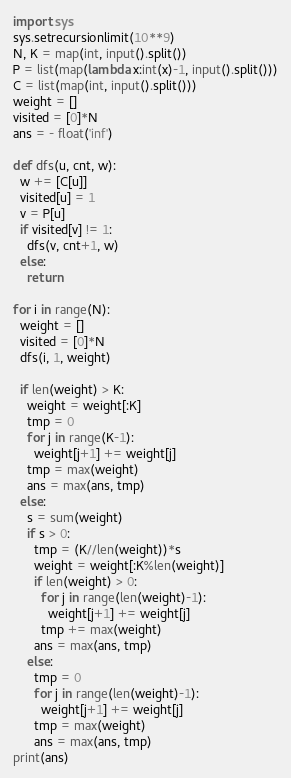Convert code to text. <code><loc_0><loc_0><loc_500><loc_500><_Python_>import sys
sys.setrecursionlimit(10**9)
N, K = map(int, input().split())
P = list(map(lambda x:int(x)-1, input().split()))
C = list(map(int, input().split()))
weight = []
visited = [0]*N
ans = - float('inf')

def dfs(u, cnt, w):
  w += [C[u]]
  visited[u] = 1
  v = P[u]
  if visited[v] != 1:
    dfs(v, cnt+1, w)
  else:
    return

for i in range(N):
  weight = []
  visited = [0]*N
  dfs(i, 1, weight)

  if len(weight) > K:
    weight = weight[:K]
    tmp = 0
    for j in range(K-1):
      weight[j+1] += weight[j]
    tmp = max(weight)
    ans = max(ans, tmp)
  else:
    s = sum(weight)
    if s > 0:
      tmp = (K//len(weight))*s
      weight = weight[:K%len(weight)]
      if len(weight) > 0:
        for j in range(len(weight)-1):
          weight[j+1] += weight[j]
        tmp += max(weight)
      ans = max(ans, tmp)
    else:
      tmp = 0
      for j in range(len(weight)-1):
        weight[j+1] += weight[j]
      tmp = max(weight)
      ans = max(ans, tmp)
print(ans)</code> 